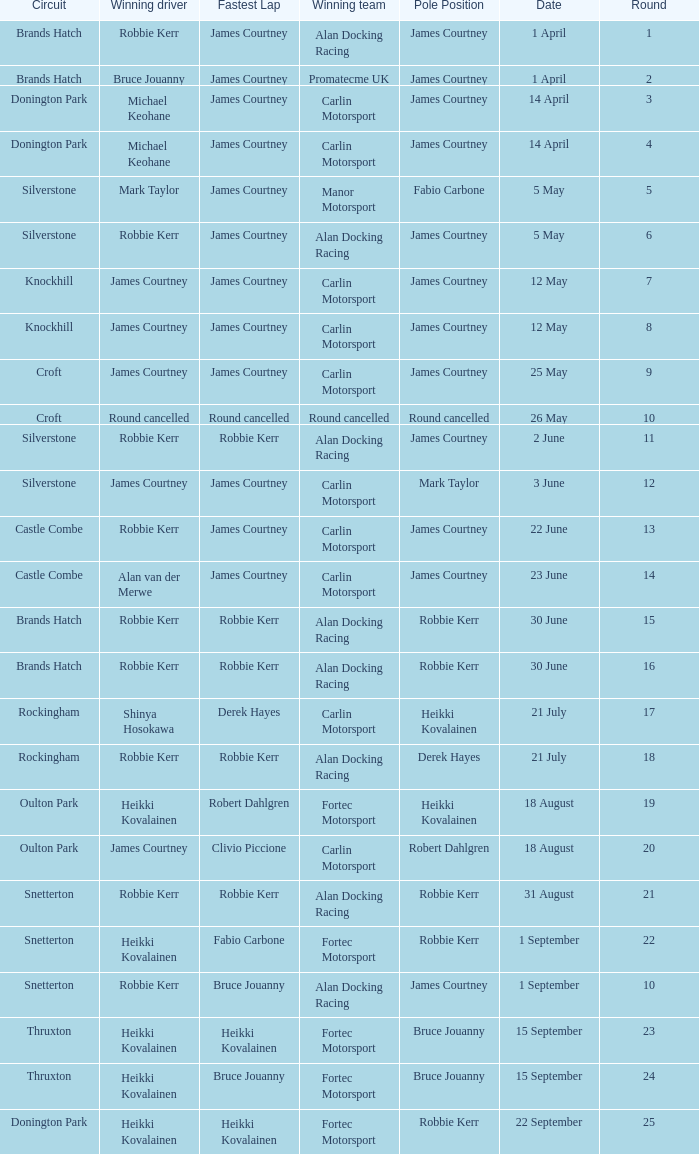How many rounds have Fabio Carbone for fastest lap? 1.0. 